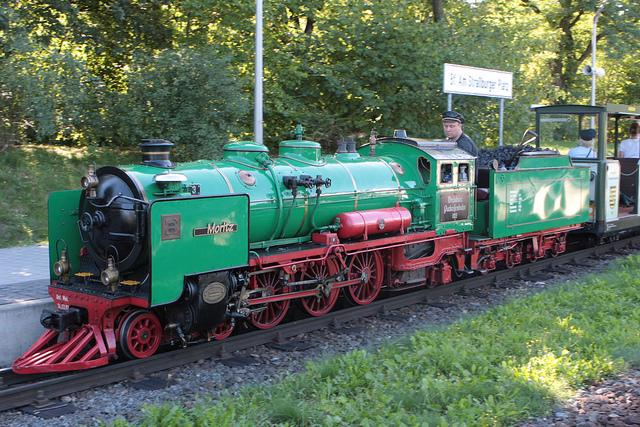What is the man doing at the front of the train car?

Choices:
A) painting
B) stopping
C) chaining
D) driving driving 